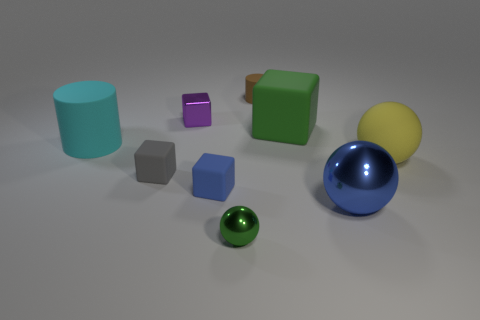How many other objects are there of the same shape as the small brown matte object?
Your answer should be very brief. 1. Are there fewer tiny gray matte things that are behind the small rubber cylinder than blue cubes to the right of the green metallic sphere?
Keep it short and to the point. No. Are there any other things that have the same color as the large rubber cylinder?
Provide a succinct answer. No. The gray object is what shape?
Keep it short and to the point. Cube. There is another tiny block that is made of the same material as the blue cube; what color is it?
Your answer should be compact. Gray. Is the number of green cylinders greater than the number of brown things?
Offer a very short reply. No. Is there a metal cube?
Offer a very short reply. Yes. There is a thing to the right of the blue object right of the big cube; what is its shape?
Your response must be concise. Sphere. What number of objects are either big red metallic cylinders or green objects that are on the right side of the small cylinder?
Offer a very short reply. 1. There is a small matte object that is behind the metal thing that is behind the rubber object on the left side of the gray matte block; what color is it?
Offer a very short reply. Brown. 